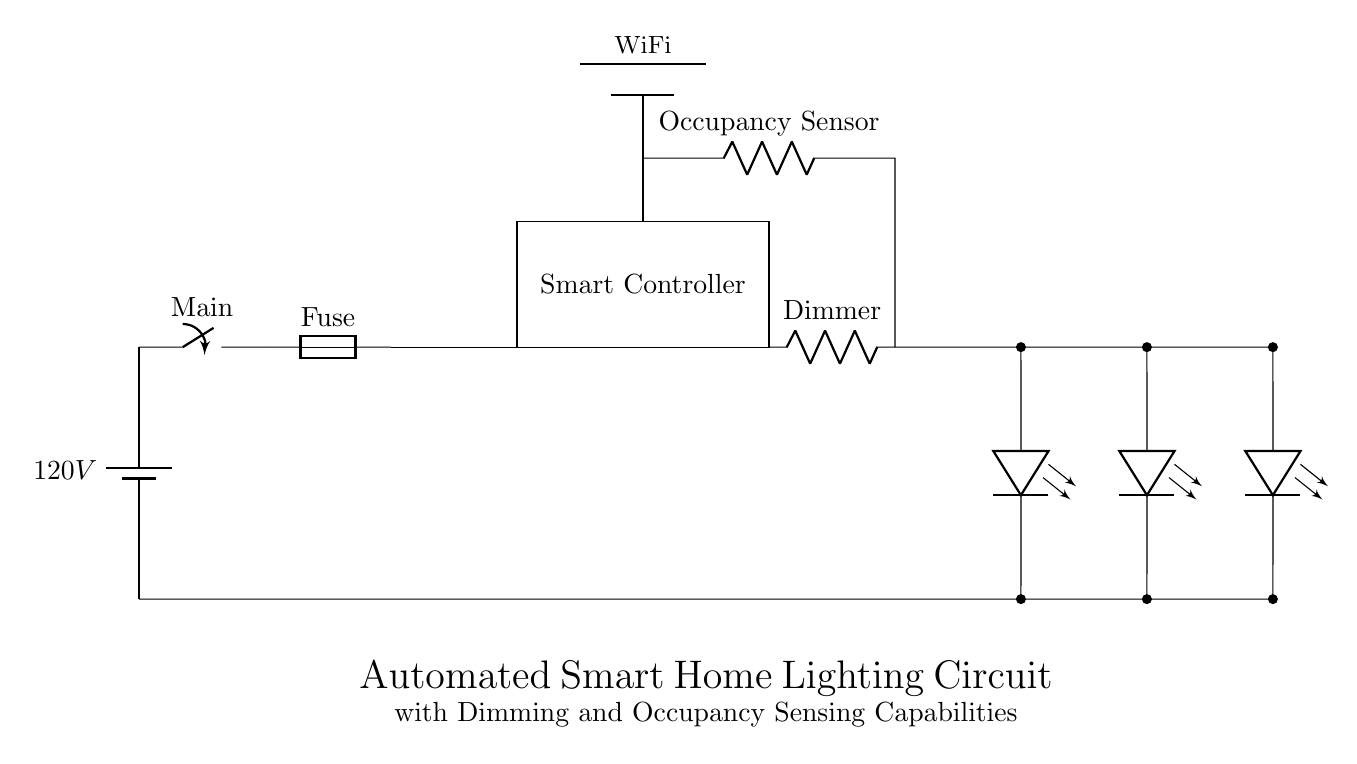What is the main voltage in this circuit? The main voltage is indicated as 120V, which is labeled next to the battery component at the beginning of the circuit diagram.
Answer: 120V What component is responsible for detecting occupancy? The occupancy sensor is directly labeled in the diagram, located above the smart controller, which identifies when a space is occupied.
Answer: Occupancy Sensor How many LED lights are present in the circuit? The circuit diagram shows three separate LED light components connected in parallel, as indicated by the three distinct leDo symbols drawn between the connections.
Answer: Three What role does the smart controller play in this circuit? The smart controller is a key component that likely manages the overall operation of the circuit, including dimming and response to the occupancy sensor, indicated by its central positioning and label in the diagram.
Answer: Smart Controller Which component is used to adjust the light intensity? The dimmer component is specifically labeled and situated in line with the circuit, which allows for the adjustment of light intensity as required.
Answer: Dimmer What is the purpose of the WiFi connection in this circuit? The WiFi connection allows for remote control or monitoring, which is essential for a smart home setup, indicated by the drawn WiFi symbol above the occupancy sensor.
Answer: Remote Control 